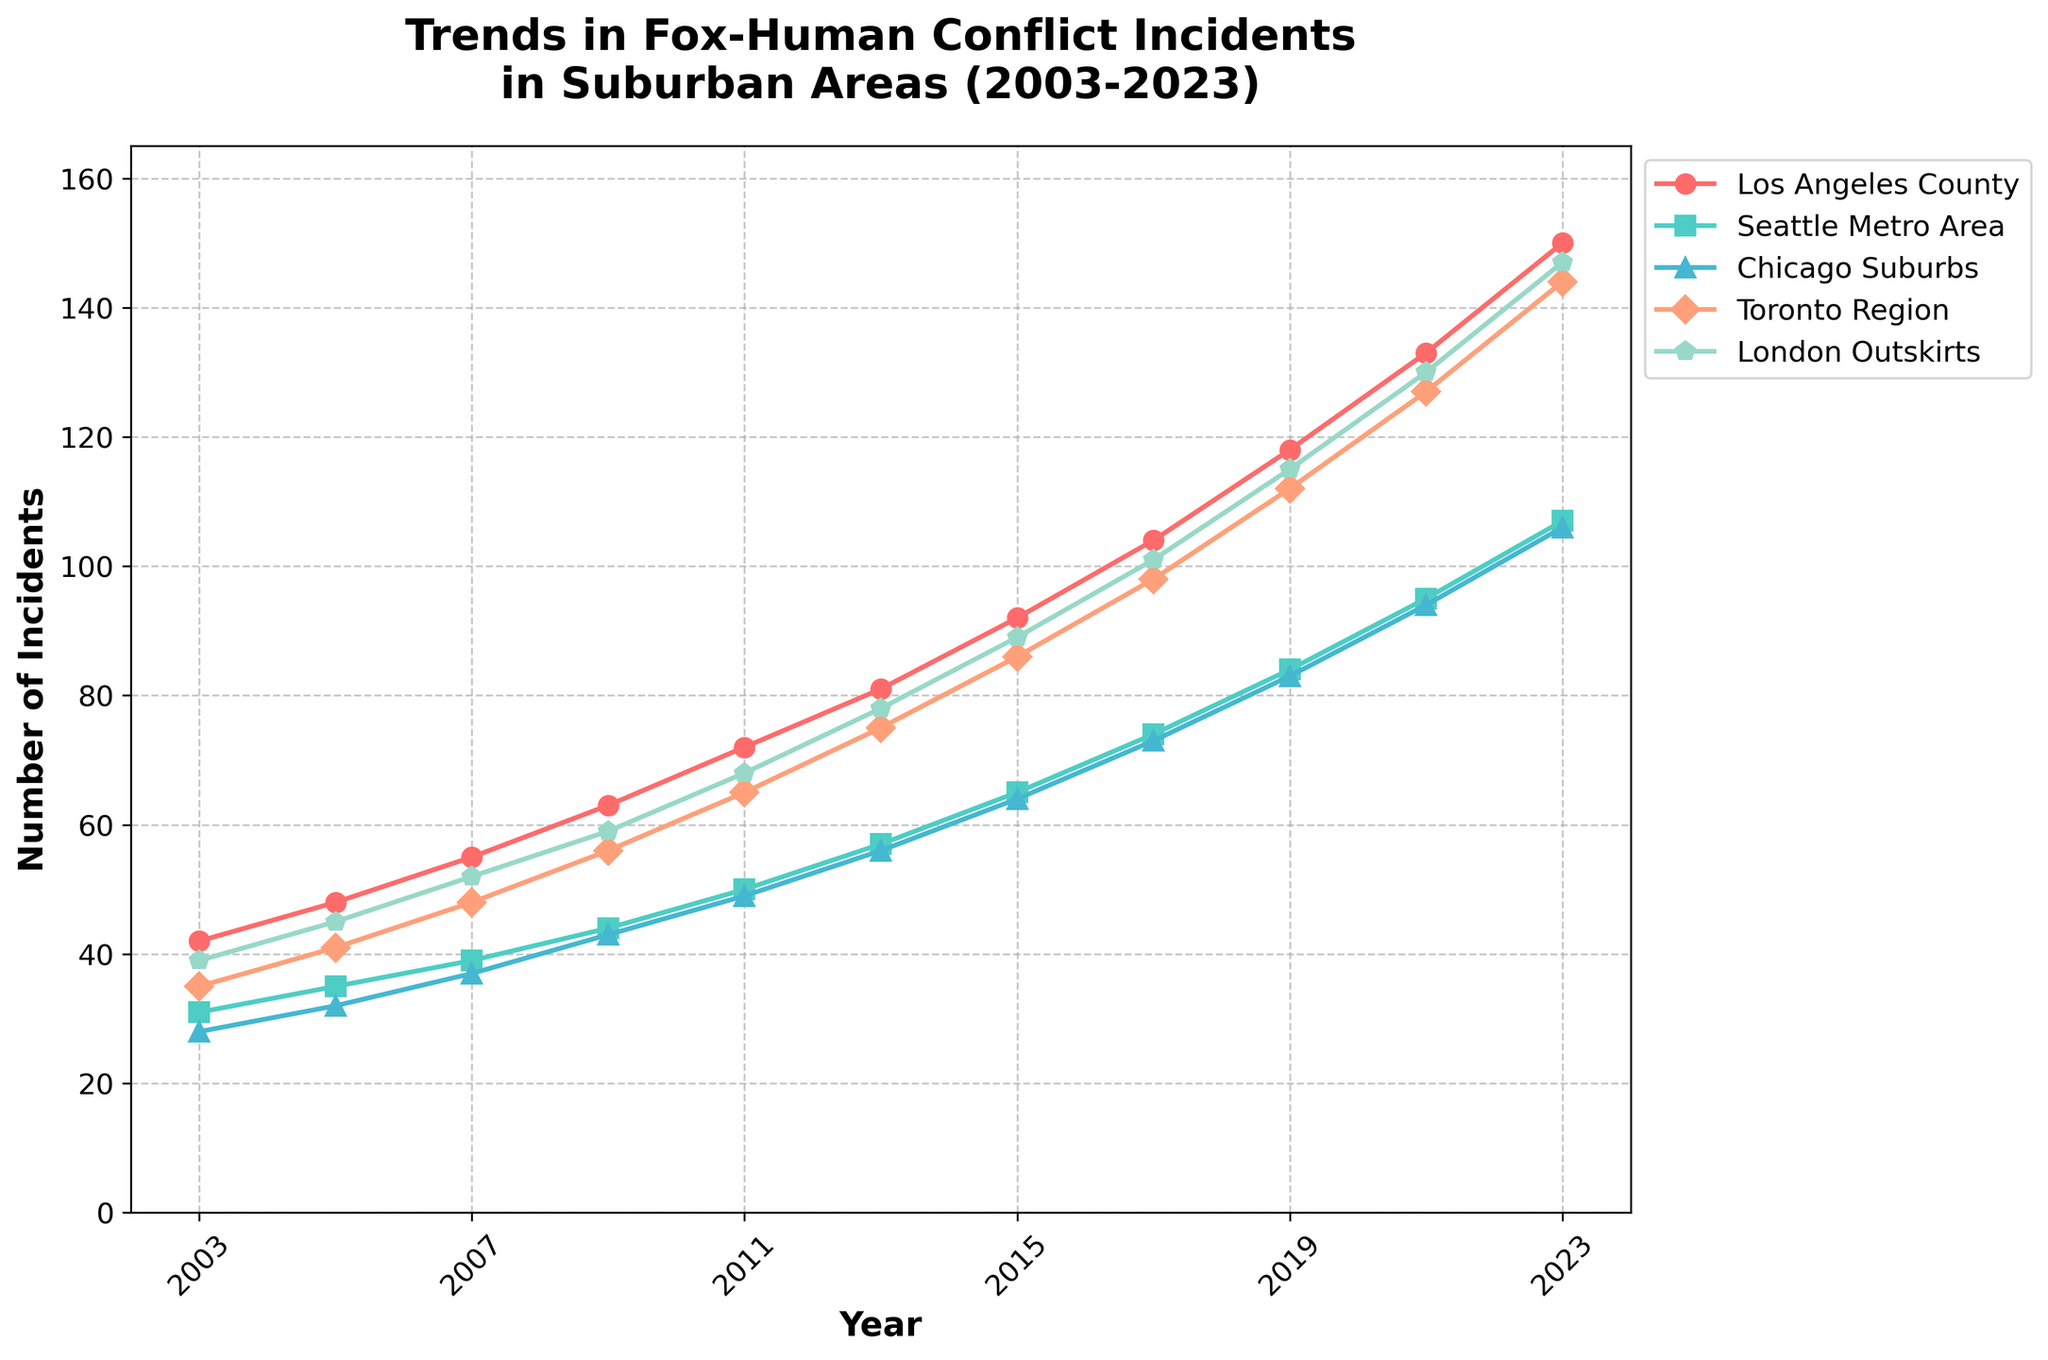What year saw the highest number of fox-human conflict incidents in Los Angeles County? Look at the plot for Los Angeles County and identify the year at the peak of the line, which is 2023.
Answer: 2023 Which suburban area showed the steepest increase in incidents between 2015 and 2017? Compare the slopes of the lines for each suburban area between 2015 and 2017. The steepest increase is represented by the line with the sharpest upward incline. London Outskirts shows the highest increase from 89 to 101.
Answer: London Outskirts Between which consecutive years did the Toronto Region experience its largest increase in incidents? Look at the Toronto Region line and find the two consecutive years with the largest vertical difference. The largest increase occurs between 2017 (98) and 2019 (112).
Answer: 2017-2019 What is the difference between the number of incidents in Chicago Suburbs and Seattle Metro Area in 2023? Check the values for Chicago Suburbs and Seattle Metro Area in 2023. Chicago Suburbs has 106 incidents, and Seattle Metro Area has 107. The difference is 106 - 107 = -1.
Answer: -1 Which area had the lowest number of incidents in 2011? Identify the number of incidents for each area in 2011. The lowest number among them is in the Chicago Suburbs with 49 incidents.
Answer: Chicago Suburbs In which year did Los Angeles County first surpass 100 incidents? Look at the Los Angeles County series and identify the first year where the incidents are greater than 100. This happens in 2017.
Answer: 2017 Calculate the average number of incidents in London Outskirts over the last decade (2013-2023). Sum the incidents in London Outskirts for the years 2013, 2015, 2017, 2019, 2021, and 2023 and divide by 6. (78 + 89 + 101 + 115 + 130 + 147) / 6 = 660 / 6.
Answer: 110 Which area showed the most consistent increase in incidents from 2003 to 2023, evidenced by the smoothest line? Assess the overall smoothness and absence of sharp dips and peaks in the lines corresponding to each area from 2003 to 2023. Los Angeles County shows the most consistent increase.
Answer: Los Angeles County By how much did the number of fox-human conflict incidents increase in the Seattle Metro Area from 2003 to 2023? Subtract the number of incidents in 2003 from that in 2023 for Seattle Metro Area. 107 (in 2023) - 31 (in 2003) = 76.
Answer: 76 Compare the trend in incidents between Los Angeles County and London Outskirts. Which area has seen a relative higher growth? Observe the starting and ending points for both lines. Los Angeles County starts at 42 and ends at 150, an increase of 108. London Outskirts starts at 39 and ends at 147, an increase of 108. Both have seen a relative increase of 108.
Answer: Both equal 